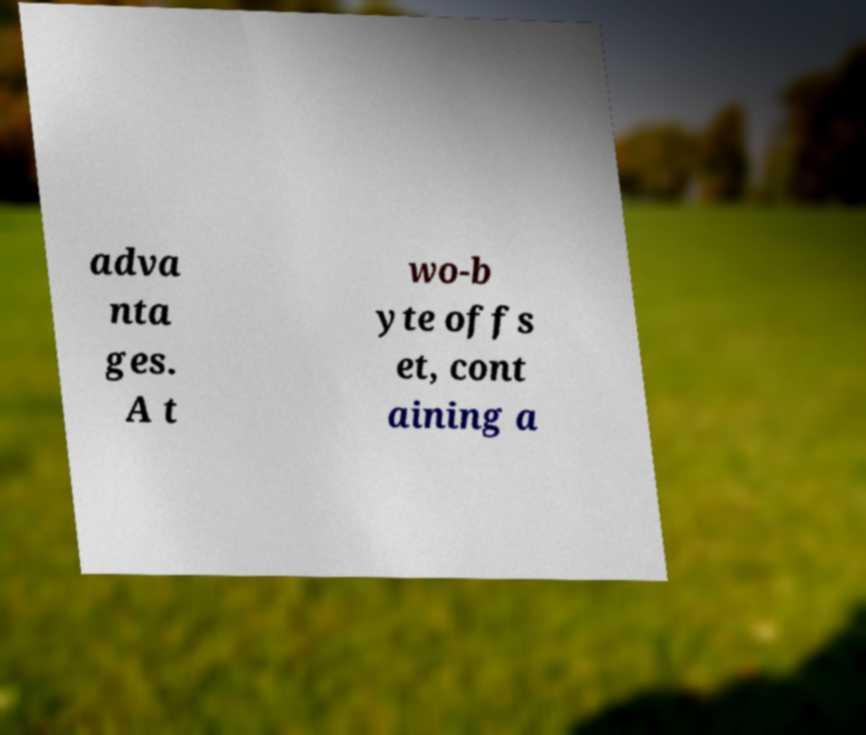I need the written content from this picture converted into text. Can you do that? adva nta ges. A t wo-b yte offs et, cont aining a 